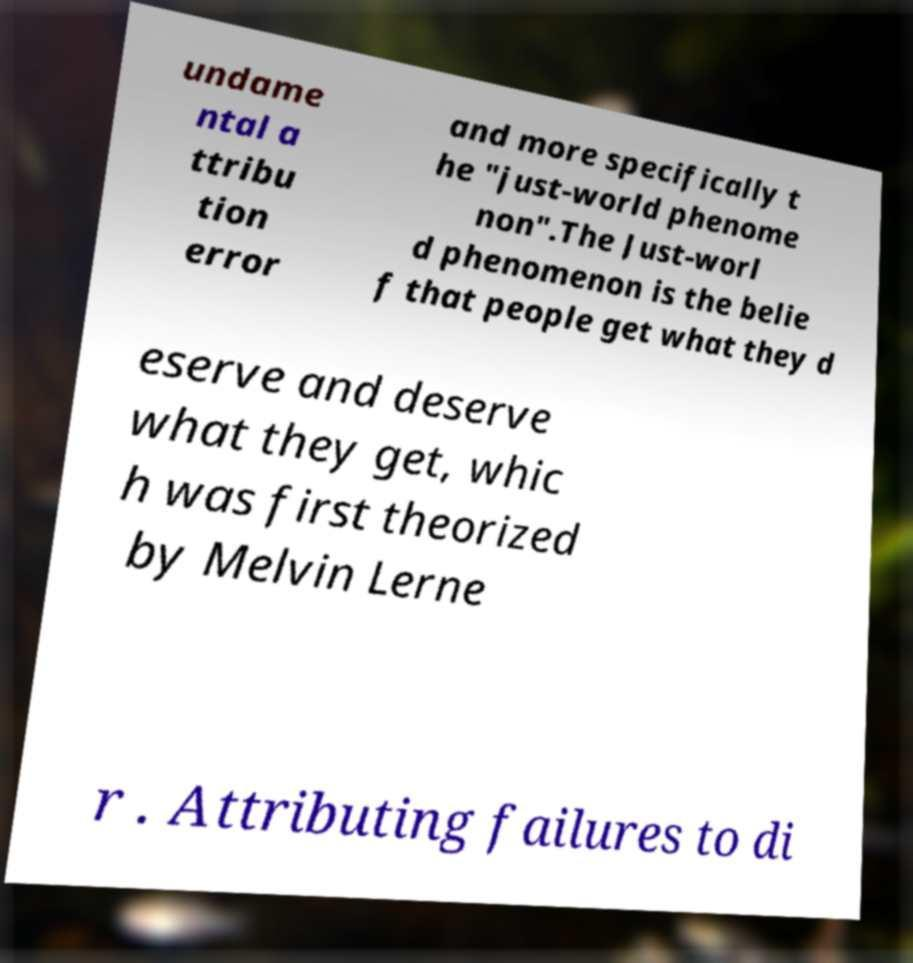What messages or text are displayed in this image? I need them in a readable, typed format. undame ntal a ttribu tion error and more specifically t he "just-world phenome non".The Just-worl d phenomenon is the belie f that people get what they d eserve and deserve what they get, whic h was first theorized by Melvin Lerne r . Attributing failures to di 